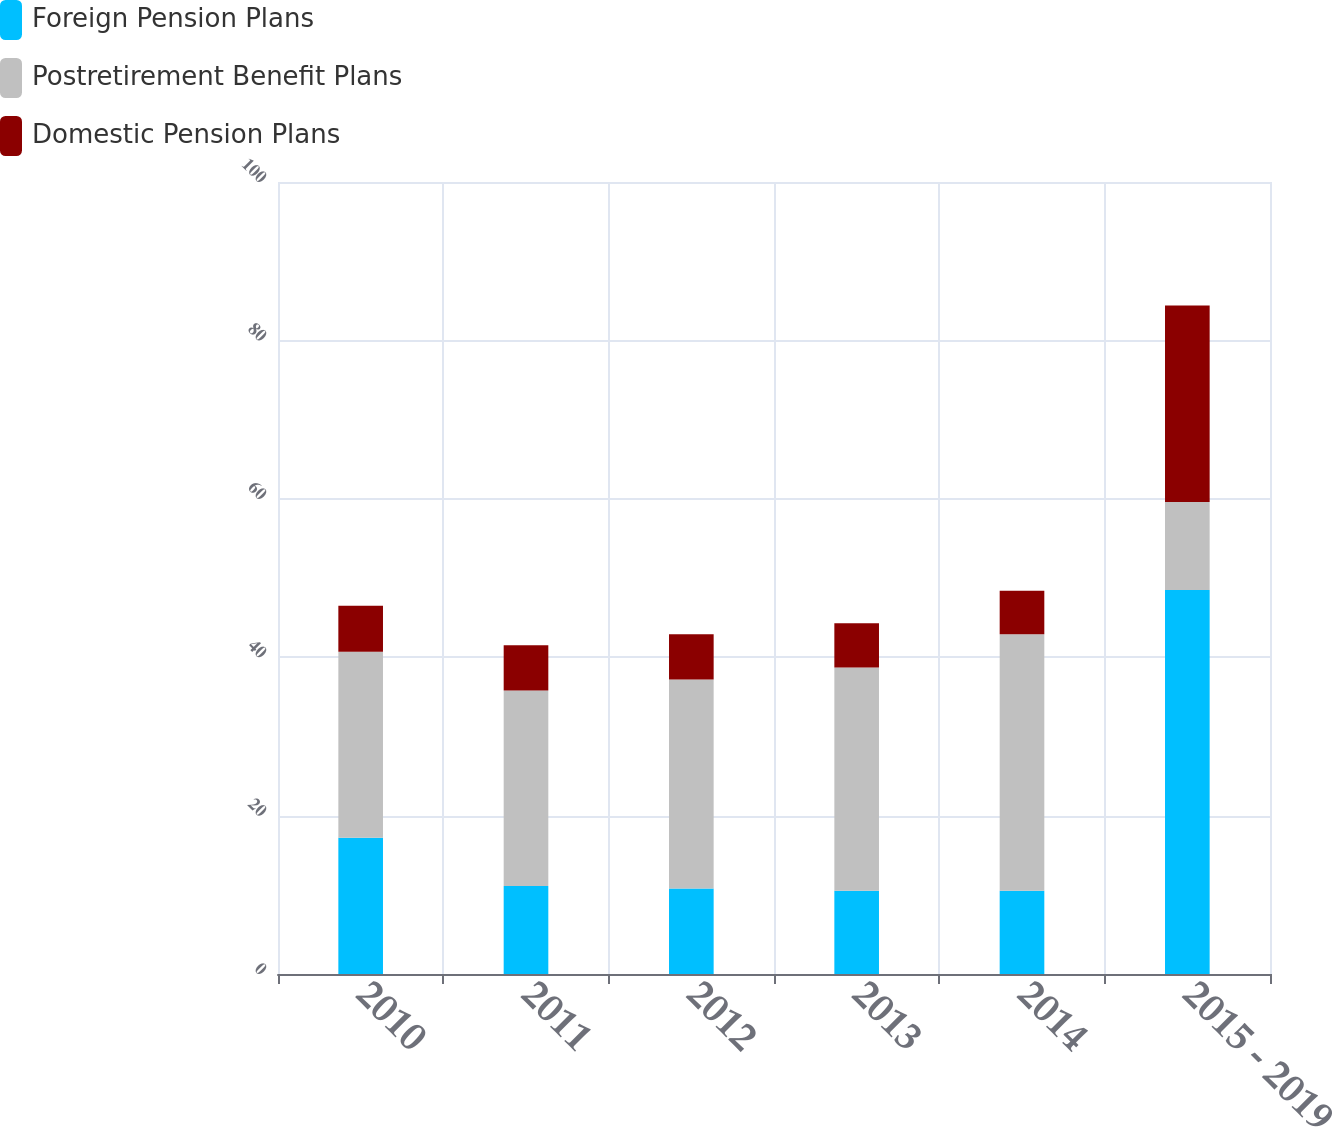Convert chart to OTSL. <chart><loc_0><loc_0><loc_500><loc_500><stacked_bar_chart><ecel><fcel>2010<fcel>2011<fcel>2012<fcel>2013<fcel>2014<fcel>2015 - 2019<nl><fcel>Foreign Pension Plans<fcel>17.2<fcel>11.1<fcel>10.8<fcel>10.5<fcel>10.5<fcel>48.5<nl><fcel>Postretirement Benefit Plans<fcel>23.5<fcel>24.7<fcel>26.4<fcel>28.2<fcel>32.4<fcel>11.1<nl><fcel>Domestic Pension Plans<fcel>5.8<fcel>5.7<fcel>5.7<fcel>5.6<fcel>5.5<fcel>24.8<nl></chart> 